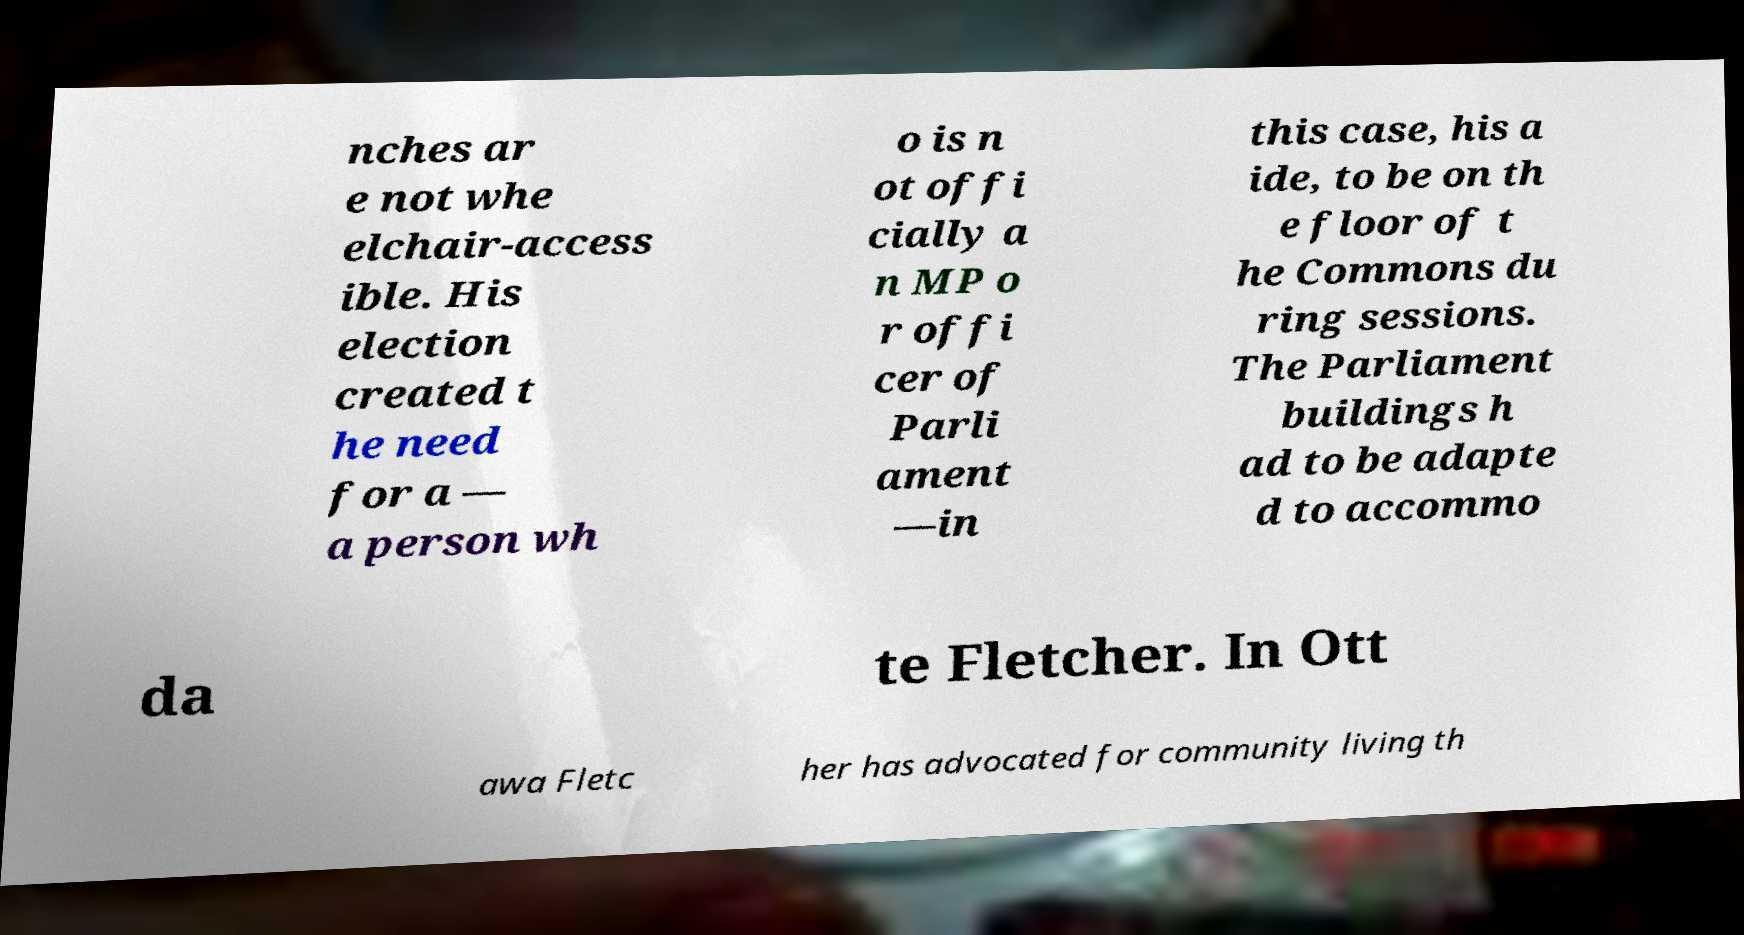Can you accurately transcribe the text from the provided image for me? nches ar e not whe elchair-access ible. His election created t he need for a — a person wh o is n ot offi cially a n MP o r offi cer of Parli ament —in this case, his a ide, to be on th e floor of t he Commons du ring sessions. The Parliament buildings h ad to be adapte d to accommo da te Fletcher. In Ott awa Fletc her has advocated for community living th 